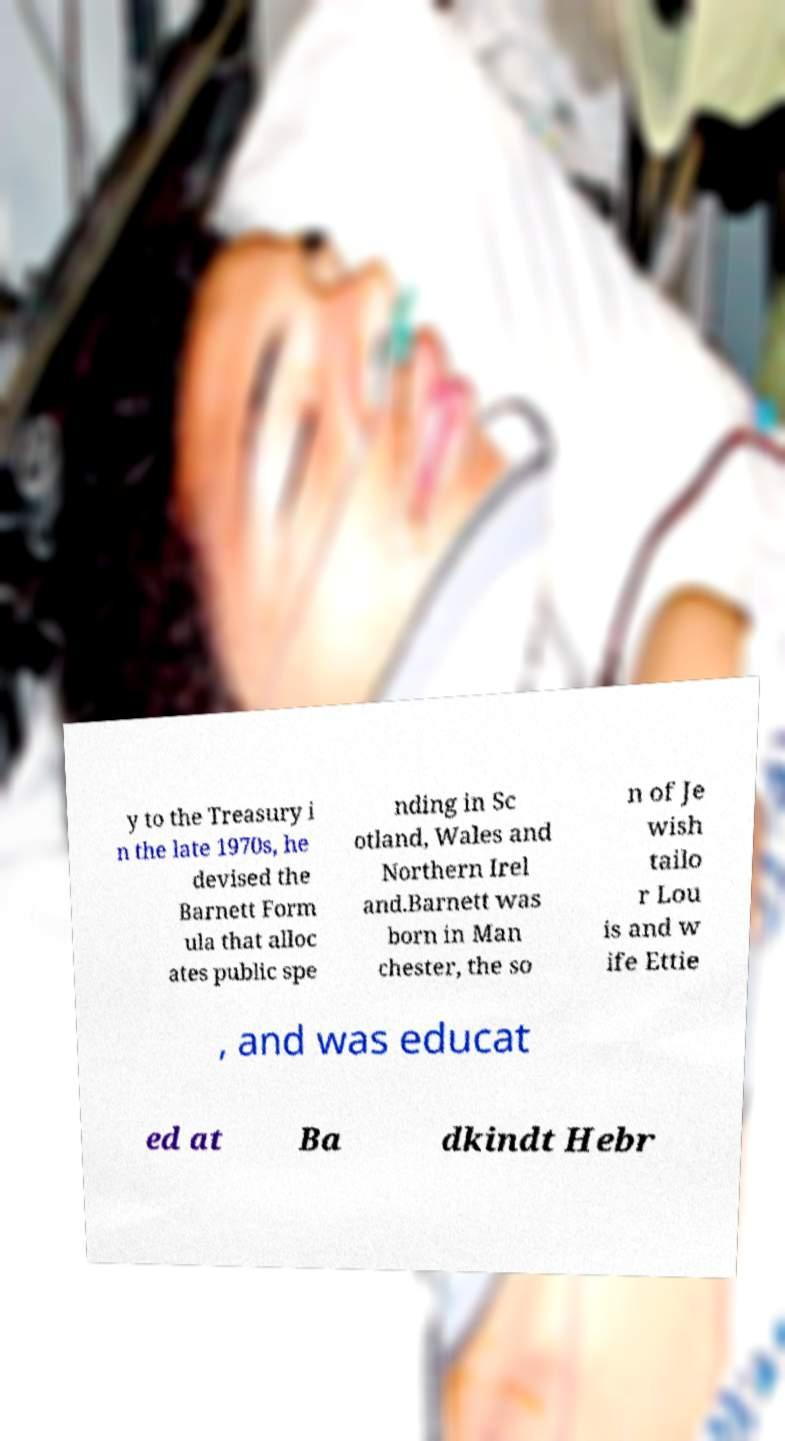Please read and relay the text visible in this image. What does it say? y to the Treasury i n the late 1970s, he devised the Barnett Form ula that alloc ates public spe nding in Sc otland, Wales and Northern Irel and.Barnett was born in Man chester, the so n of Je wish tailo r Lou is and w ife Ettie , and was educat ed at Ba dkindt Hebr 